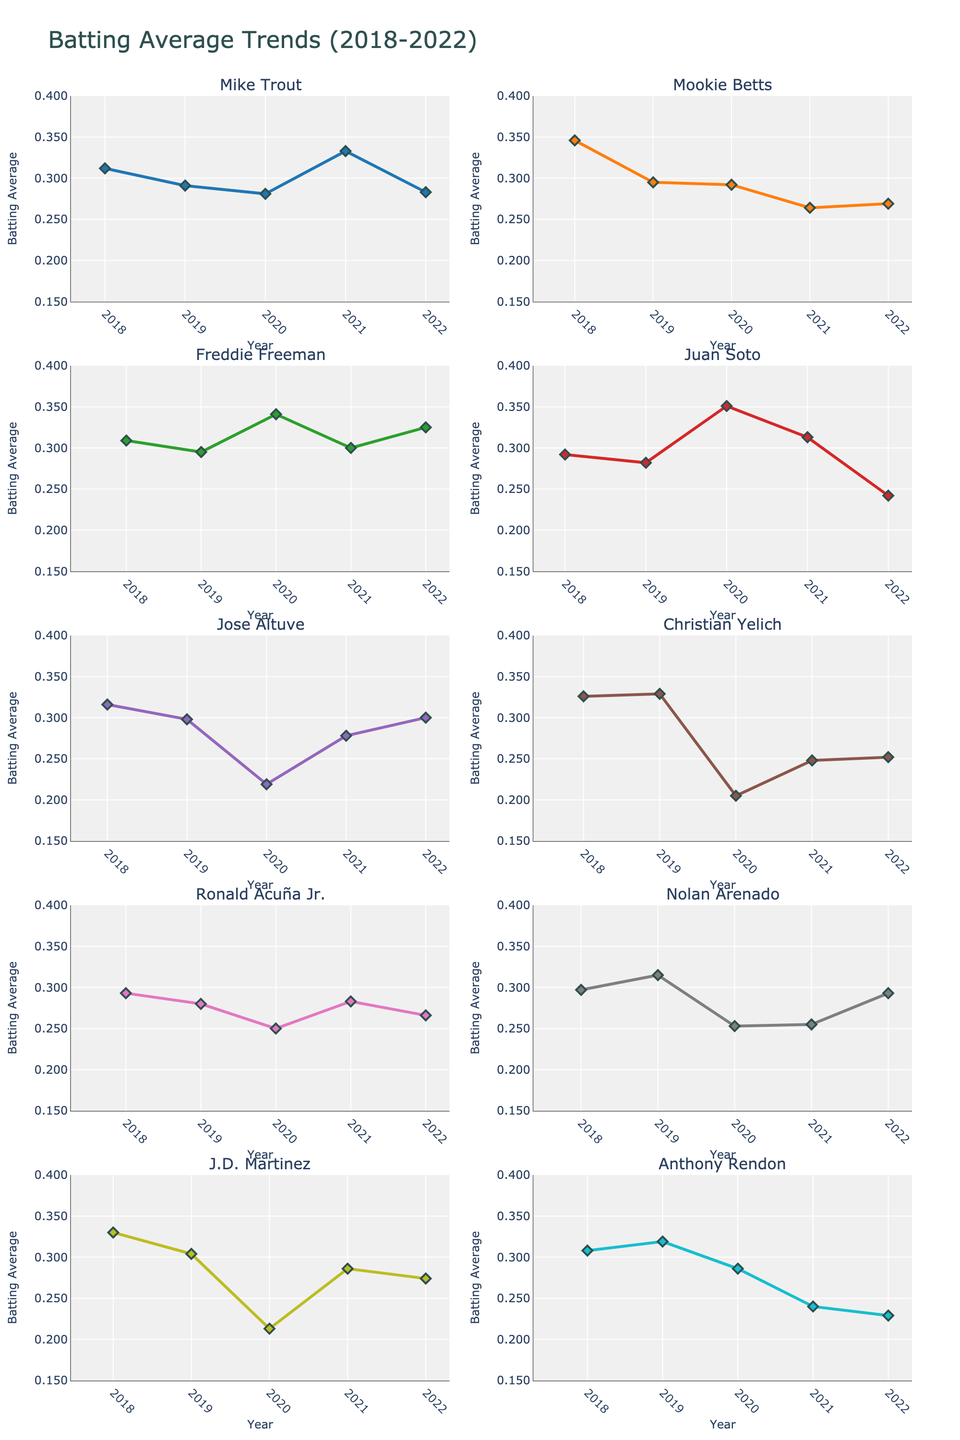What is the title of the figure? The title is displayed at the top of the figure. It summarizes the overall theme being analyzed. In this case, the title "Batting Average Trends (2018-2022)" indicates the subject of the line charts, which are the batting average trends of players from 2018 to 2022.
Answer: "Batting Average Trends (2018-2022)" Which player has the highest batting average in 2020? To find out who has the highest batting average in 2020, we examine the y-values (batting averages) for all the players at the 2020 x-position. Juan Soto has the highest value, 0.351.
Answer: Juan Soto Who shows the most significant improvement in batting average from 2018 to 2022? To determine this, subtract the 2018 batting averages from the 2022 values for each player and compare the differences. Freddie Freeman improves from 0.309 (2018) to 0.325 (2022), indicating improvement. However, the biggest positive change appears for Jose Altuve who went from 0.316 (2018) to 0.300 (2022) but had a larger drop and recovery overall compared to others.
Answer: Freddie Freeman Which player had the lowest batting average in 2020, and what was it? To determine the player with the lowest batting average in 2020, compare the y-values for all players at the 2020 x-position. Christian Yelich has the lowest batting average at 0.205.
Answer: Christian Yelich, 0.205 Which years did Mike Trout have a batting average above 0.300? Examine Mike Trout's data line and identify the years where the y-values exceed 0.300. Mike Trout has batting averages above 0.300 in 2018 (0.312) and 2021 (0.333).
Answer: 2018, 2021 Who had the most consistent batting average over the five years, and how do you determine consistency? Consistency can be measured in terms of variance or mean deviation from the average. By visually assessing the smoothness and closeness of data points, Freddie Freeman appears to have the most consistent batting averages between 0.295 and 0.341 over the five-year span.
Answer: Freddie Freeman Which player's batting average decreased the most from 2019 to 2020? To determine the largest decrease from 2019 to 2020, compare the batting averages of each player for those specific years and calculate the differences. The player with the most significant drop is Anthony Rendon, who went from 0.319 in 2019 to 0.286 in 2020.
Answer: Anthony Rendon How many players had their highest batting average in the year 2018? Check each player's batting average for the year 2018 and see if it is the maximum across the five years for that player. By comparing, Mike Trout (0.312), Mookie Betts (0.346), Jose Altuve (0.316), Christian Yelich (0.326), Ronald Acuña Jr. (0.293), and J.D. Martinez (0.330) had their highest averages in 2018. Count the players: 6.
Answer: 6 